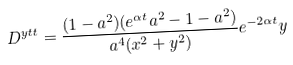Convert formula to latex. <formula><loc_0><loc_0><loc_500><loc_500>D ^ { y t t } = \frac { ( 1 - a ^ { 2 } ) ( e ^ { \alpha t } a ^ { 2 } - 1 - a ^ { 2 } ) } { a ^ { 4 } ( x ^ { 2 } + y ^ { 2 } ) } e ^ { - 2 \alpha t } y</formula> 